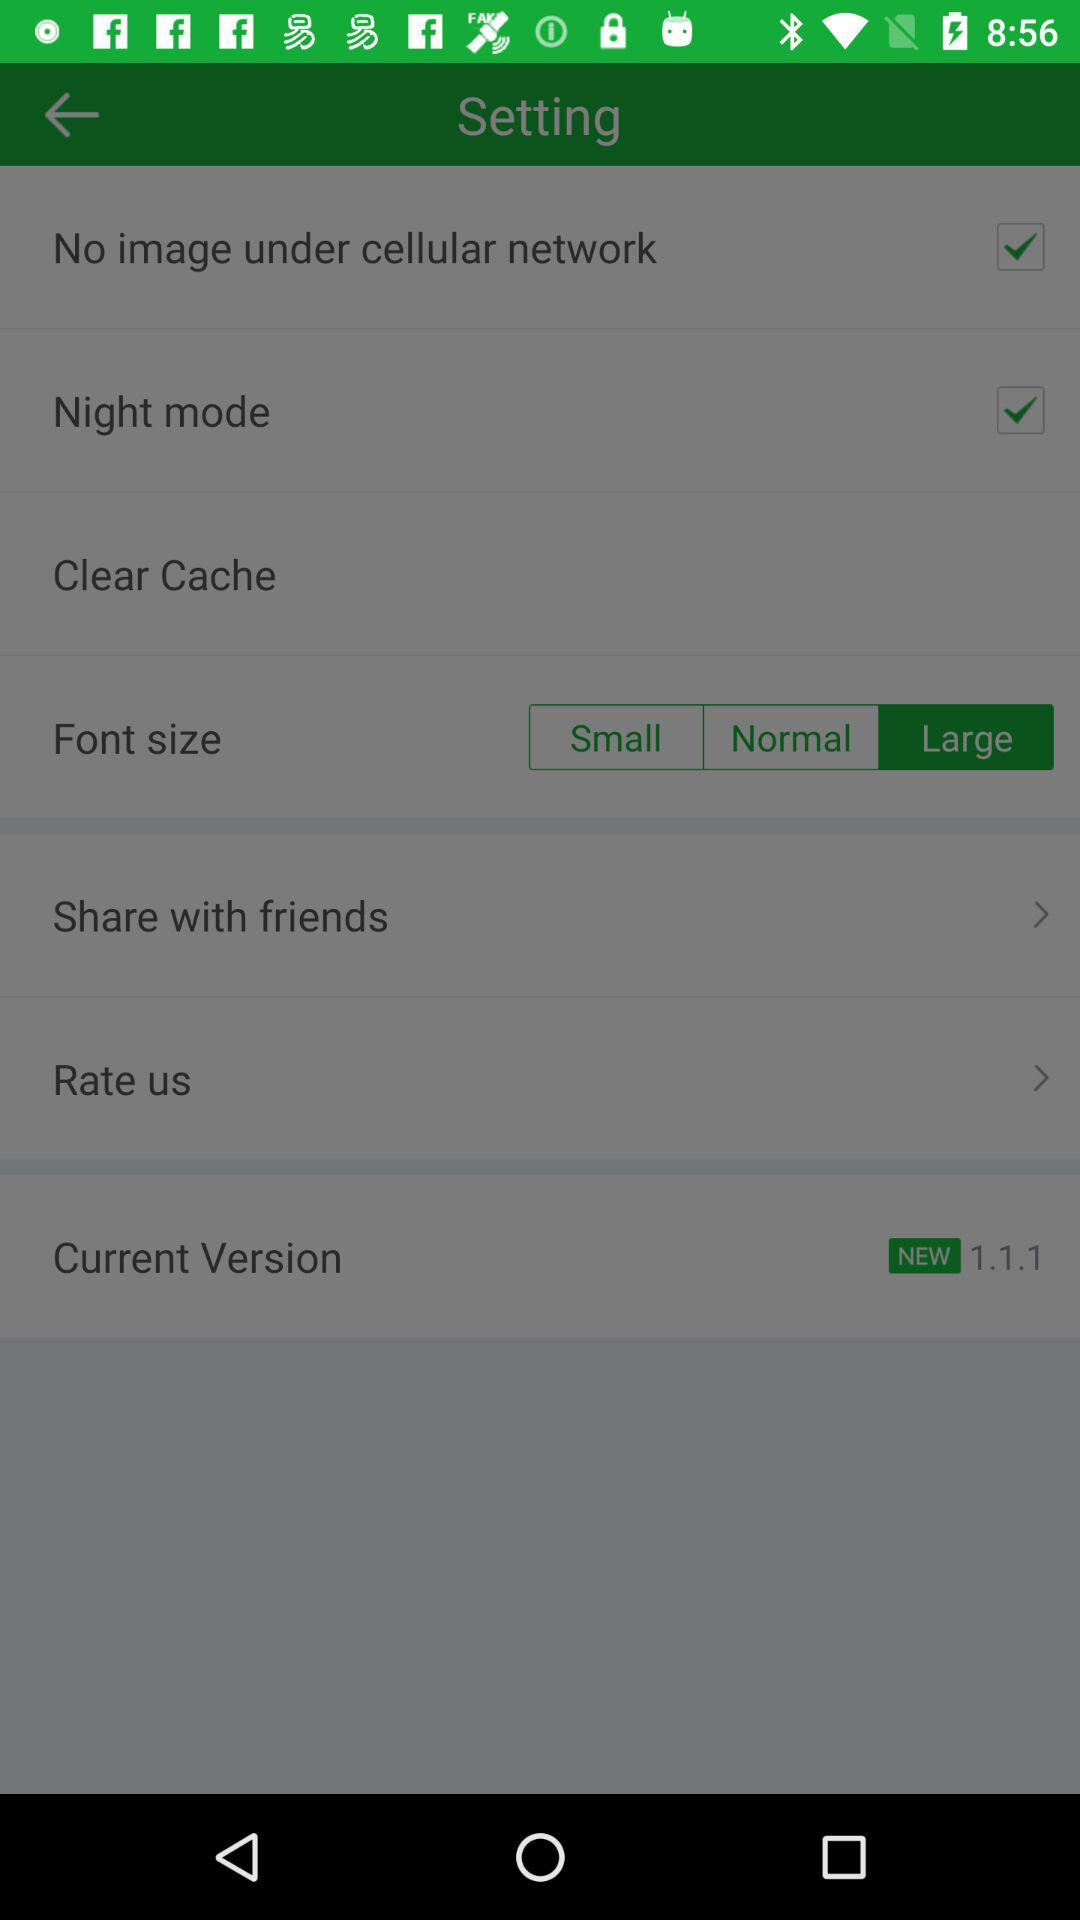What are the checked settings? The checked settings are "No image under cellular network" and "Night mode". 